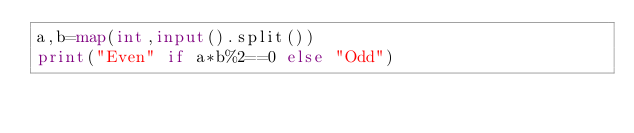Convert code to text. <code><loc_0><loc_0><loc_500><loc_500><_Python_>a,b=map(int,input().split())
print("Even" if a*b%2==0 else "Odd")</code> 